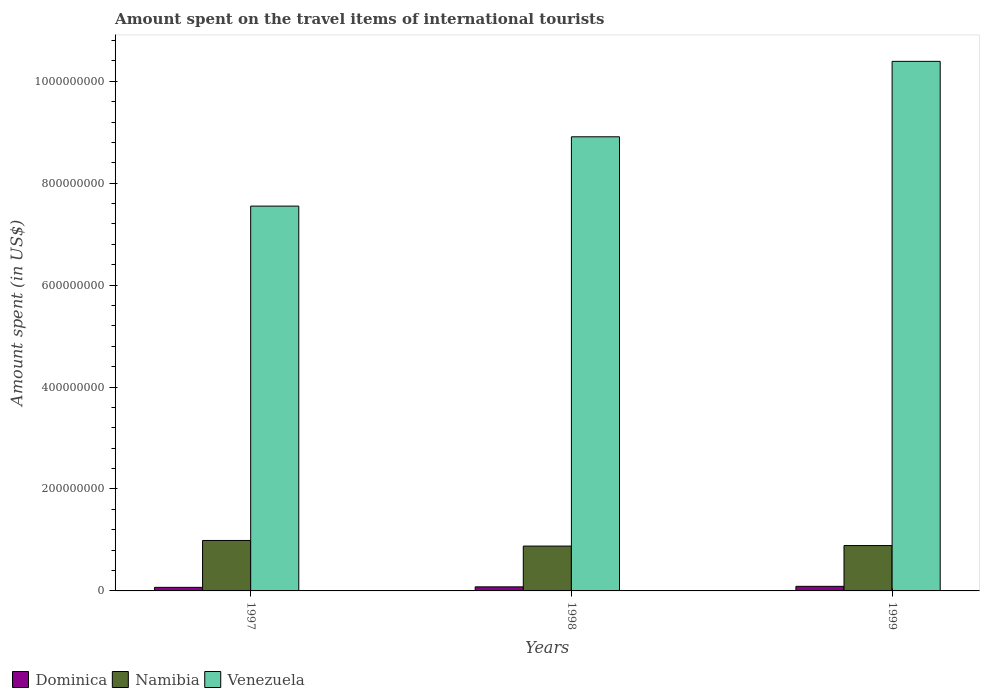In how many cases, is the number of bars for a given year not equal to the number of legend labels?
Offer a very short reply. 0. What is the amount spent on the travel items of international tourists in Namibia in 1998?
Offer a very short reply. 8.80e+07. Across all years, what is the maximum amount spent on the travel items of international tourists in Namibia?
Provide a succinct answer. 9.90e+07. Across all years, what is the minimum amount spent on the travel items of international tourists in Venezuela?
Provide a succinct answer. 7.55e+08. In which year was the amount spent on the travel items of international tourists in Venezuela maximum?
Provide a short and direct response. 1999. In which year was the amount spent on the travel items of international tourists in Dominica minimum?
Ensure brevity in your answer.  1997. What is the total amount spent on the travel items of international tourists in Dominica in the graph?
Offer a very short reply. 2.40e+07. What is the difference between the amount spent on the travel items of international tourists in Namibia in 1997 and that in 1998?
Your response must be concise. 1.10e+07. What is the difference between the amount spent on the travel items of international tourists in Venezuela in 1998 and the amount spent on the travel items of international tourists in Namibia in 1999?
Your answer should be very brief. 8.02e+08. What is the average amount spent on the travel items of international tourists in Venezuela per year?
Ensure brevity in your answer.  8.95e+08. In the year 1997, what is the difference between the amount spent on the travel items of international tourists in Dominica and amount spent on the travel items of international tourists in Venezuela?
Ensure brevity in your answer.  -7.48e+08. What is the ratio of the amount spent on the travel items of international tourists in Venezuela in 1998 to that in 1999?
Your answer should be compact. 0.86. Is the difference between the amount spent on the travel items of international tourists in Dominica in 1997 and 1998 greater than the difference between the amount spent on the travel items of international tourists in Venezuela in 1997 and 1998?
Your response must be concise. Yes. What is the difference between the highest and the second highest amount spent on the travel items of international tourists in Venezuela?
Ensure brevity in your answer.  1.48e+08. What is the difference between the highest and the lowest amount spent on the travel items of international tourists in Venezuela?
Provide a short and direct response. 2.84e+08. Is the sum of the amount spent on the travel items of international tourists in Dominica in 1997 and 1999 greater than the maximum amount spent on the travel items of international tourists in Namibia across all years?
Provide a short and direct response. No. What does the 3rd bar from the left in 1998 represents?
Your answer should be compact. Venezuela. What does the 2nd bar from the right in 1997 represents?
Provide a short and direct response. Namibia. Is it the case that in every year, the sum of the amount spent on the travel items of international tourists in Namibia and amount spent on the travel items of international tourists in Venezuela is greater than the amount spent on the travel items of international tourists in Dominica?
Your answer should be very brief. Yes. How many bars are there?
Your answer should be compact. 9. Are all the bars in the graph horizontal?
Your response must be concise. No. What is the difference between two consecutive major ticks on the Y-axis?
Your answer should be very brief. 2.00e+08. Does the graph contain any zero values?
Offer a terse response. No. Does the graph contain grids?
Your answer should be compact. No. Where does the legend appear in the graph?
Offer a very short reply. Bottom left. What is the title of the graph?
Give a very brief answer. Amount spent on the travel items of international tourists. What is the label or title of the Y-axis?
Offer a terse response. Amount spent (in US$). What is the Amount spent (in US$) of Dominica in 1997?
Keep it short and to the point. 7.00e+06. What is the Amount spent (in US$) of Namibia in 1997?
Make the answer very short. 9.90e+07. What is the Amount spent (in US$) of Venezuela in 1997?
Provide a short and direct response. 7.55e+08. What is the Amount spent (in US$) in Namibia in 1998?
Offer a very short reply. 8.80e+07. What is the Amount spent (in US$) of Venezuela in 1998?
Offer a terse response. 8.91e+08. What is the Amount spent (in US$) in Dominica in 1999?
Your answer should be very brief. 9.00e+06. What is the Amount spent (in US$) in Namibia in 1999?
Provide a short and direct response. 8.90e+07. What is the Amount spent (in US$) of Venezuela in 1999?
Ensure brevity in your answer.  1.04e+09. Across all years, what is the maximum Amount spent (in US$) of Dominica?
Give a very brief answer. 9.00e+06. Across all years, what is the maximum Amount spent (in US$) of Namibia?
Ensure brevity in your answer.  9.90e+07. Across all years, what is the maximum Amount spent (in US$) in Venezuela?
Give a very brief answer. 1.04e+09. Across all years, what is the minimum Amount spent (in US$) of Namibia?
Offer a terse response. 8.80e+07. Across all years, what is the minimum Amount spent (in US$) in Venezuela?
Give a very brief answer. 7.55e+08. What is the total Amount spent (in US$) of Dominica in the graph?
Make the answer very short. 2.40e+07. What is the total Amount spent (in US$) in Namibia in the graph?
Your answer should be compact. 2.76e+08. What is the total Amount spent (in US$) of Venezuela in the graph?
Keep it short and to the point. 2.68e+09. What is the difference between the Amount spent (in US$) in Namibia in 1997 and that in 1998?
Your answer should be compact. 1.10e+07. What is the difference between the Amount spent (in US$) of Venezuela in 1997 and that in 1998?
Your answer should be compact. -1.36e+08. What is the difference between the Amount spent (in US$) in Dominica in 1997 and that in 1999?
Keep it short and to the point. -2.00e+06. What is the difference between the Amount spent (in US$) in Namibia in 1997 and that in 1999?
Provide a succinct answer. 1.00e+07. What is the difference between the Amount spent (in US$) of Venezuela in 1997 and that in 1999?
Your answer should be very brief. -2.84e+08. What is the difference between the Amount spent (in US$) in Dominica in 1998 and that in 1999?
Your answer should be compact. -1.00e+06. What is the difference between the Amount spent (in US$) in Venezuela in 1998 and that in 1999?
Give a very brief answer. -1.48e+08. What is the difference between the Amount spent (in US$) in Dominica in 1997 and the Amount spent (in US$) in Namibia in 1998?
Your response must be concise. -8.10e+07. What is the difference between the Amount spent (in US$) in Dominica in 1997 and the Amount spent (in US$) in Venezuela in 1998?
Make the answer very short. -8.84e+08. What is the difference between the Amount spent (in US$) in Namibia in 1997 and the Amount spent (in US$) in Venezuela in 1998?
Provide a short and direct response. -7.92e+08. What is the difference between the Amount spent (in US$) in Dominica in 1997 and the Amount spent (in US$) in Namibia in 1999?
Provide a short and direct response. -8.20e+07. What is the difference between the Amount spent (in US$) of Dominica in 1997 and the Amount spent (in US$) of Venezuela in 1999?
Keep it short and to the point. -1.03e+09. What is the difference between the Amount spent (in US$) of Namibia in 1997 and the Amount spent (in US$) of Venezuela in 1999?
Make the answer very short. -9.40e+08. What is the difference between the Amount spent (in US$) in Dominica in 1998 and the Amount spent (in US$) in Namibia in 1999?
Keep it short and to the point. -8.10e+07. What is the difference between the Amount spent (in US$) of Dominica in 1998 and the Amount spent (in US$) of Venezuela in 1999?
Provide a succinct answer. -1.03e+09. What is the difference between the Amount spent (in US$) in Namibia in 1998 and the Amount spent (in US$) in Venezuela in 1999?
Make the answer very short. -9.51e+08. What is the average Amount spent (in US$) in Namibia per year?
Offer a terse response. 9.20e+07. What is the average Amount spent (in US$) of Venezuela per year?
Provide a succinct answer. 8.95e+08. In the year 1997, what is the difference between the Amount spent (in US$) of Dominica and Amount spent (in US$) of Namibia?
Offer a very short reply. -9.20e+07. In the year 1997, what is the difference between the Amount spent (in US$) of Dominica and Amount spent (in US$) of Venezuela?
Offer a terse response. -7.48e+08. In the year 1997, what is the difference between the Amount spent (in US$) in Namibia and Amount spent (in US$) in Venezuela?
Your answer should be very brief. -6.56e+08. In the year 1998, what is the difference between the Amount spent (in US$) in Dominica and Amount spent (in US$) in Namibia?
Provide a short and direct response. -8.00e+07. In the year 1998, what is the difference between the Amount spent (in US$) in Dominica and Amount spent (in US$) in Venezuela?
Offer a terse response. -8.83e+08. In the year 1998, what is the difference between the Amount spent (in US$) of Namibia and Amount spent (in US$) of Venezuela?
Your answer should be compact. -8.03e+08. In the year 1999, what is the difference between the Amount spent (in US$) in Dominica and Amount spent (in US$) in Namibia?
Make the answer very short. -8.00e+07. In the year 1999, what is the difference between the Amount spent (in US$) of Dominica and Amount spent (in US$) of Venezuela?
Ensure brevity in your answer.  -1.03e+09. In the year 1999, what is the difference between the Amount spent (in US$) of Namibia and Amount spent (in US$) of Venezuela?
Provide a succinct answer. -9.50e+08. What is the ratio of the Amount spent (in US$) in Dominica in 1997 to that in 1998?
Ensure brevity in your answer.  0.88. What is the ratio of the Amount spent (in US$) of Namibia in 1997 to that in 1998?
Provide a short and direct response. 1.12. What is the ratio of the Amount spent (in US$) of Venezuela in 1997 to that in 1998?
Provide a short and direct response. 0.85. What is the ratio of the Amount spent (in US$) of Dominica in 1997 to that in 1999?
Your response must be concise. 0.78. What is the ratio of the Amount spent (in US$) in Namibia in 1997 to that in 1999?
Offer a very short reply. 1.11. What is the ratio of the Amount spent (in US$) of Venezuela in 1997 to that in 1999?
Offer a terse response. 0.73. What is the ratio of the Amount spent (in US$) in Dominica in 1998 to that in 1999?
Make the answer very short. 0.89. What is the ratio of the Amount spent (in US$) of Venezuela in 1998 to that in 1999?
Your answer should be very brief. 0.86. What is the difference between the highest and the second highest Amount spent (in US$) of Dominica?
Your answer should be compact. 1.00e+06. What is the difference between the highest and the second highest Amount spent (in US$) in Venezuela?
Give a very brief answer. 1.48e+08. What is the difference between the highest and the lowest Amount spent (in US$) in Namibia?
Provide a short and direct response. 1.10e+07. What is the difference between the highest and the lowest Amount spent (in US$) of Venezuela?
Give a very brief answer. 2.84e+08. 